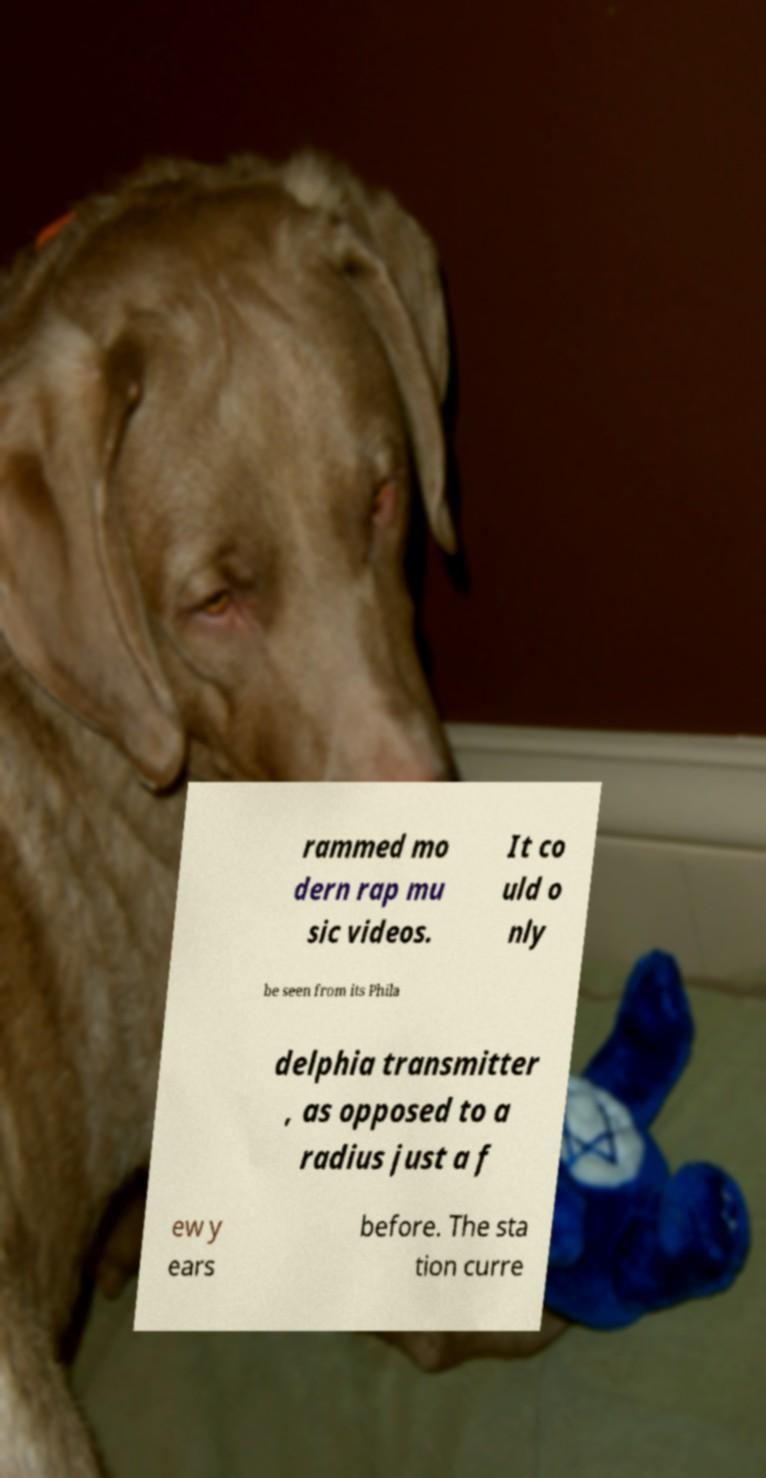Could you extract and type out the text from this image? rammed mo dern rap mu sic videos. It co uld o nly be seen from its Phila delphia transmitter , as opposed to a radius just a f ew y ears before. The sta tion curre 